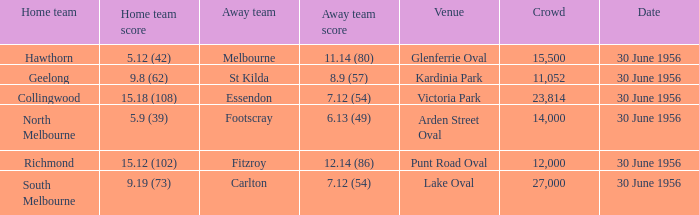What is the home team score when the away team is Melbourne? 5.12 (42). 